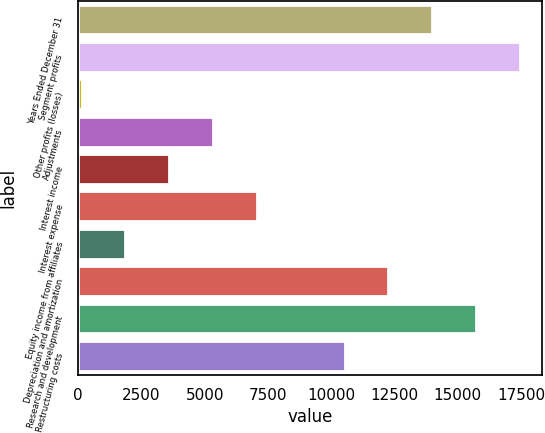<chart> <loc_0><loc_0><loc_500><loc_500><bar_chart><fcel>Years Ended December 31<fcel>Segment profits<fcel>Other profits (losses)<fcel>Adjustments<fcel>Interest income<fcel>Interest expense<fcel>Equity income from affiliates<fcel>Depreciation and amortization<fcel>Research and development<fcel>Restructuring costs<nl><fcel>13987.4<fcel>17450<fcel>137<fcel>5330.9<fcel>3599.6<fcel>7062.2<fcel>1868.3<fcel>12256.1<fcel>15718.7<fcel>10524.8<nl></chart> 